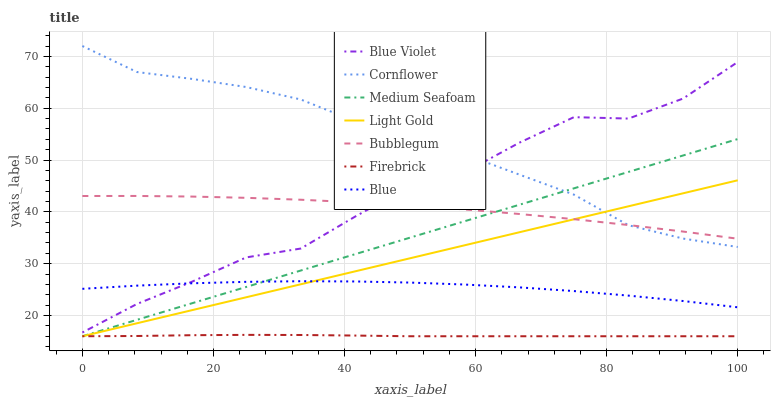Does Firebrick have the minimum area under the curve?
Answer yes or no. Yes. Does Cornflower have the maximum area under the curve?
Answer yes or no. Yes. Does Cornflower have the minimum area under the curve?
Answer yes or no. No. Does Firebrick have the maximum area under the curve?
Answer yes or no. No. Is Medium Seafoam the smoothest?
Answer yes or no. Yes. Is Blue Violet the roughest?
Answer yes or no. Yes. Is Cornflower the smoothest?
Answer yes or no. No. Is Cornflower the roughest?
Answer yes or no. No. Does Cornflower have the lowest value?
Answer yes or no. No. Does Firebrick have the highest value?
Answer yes or no. No. Is Light Gold less than Blue Violet?
Answer yes or no. Yes. Is Bubblegum greater than Blue?
Answer yes or no. Yes. Does Light Gold intersect Blue Violet?
Answer yes or no. No. 